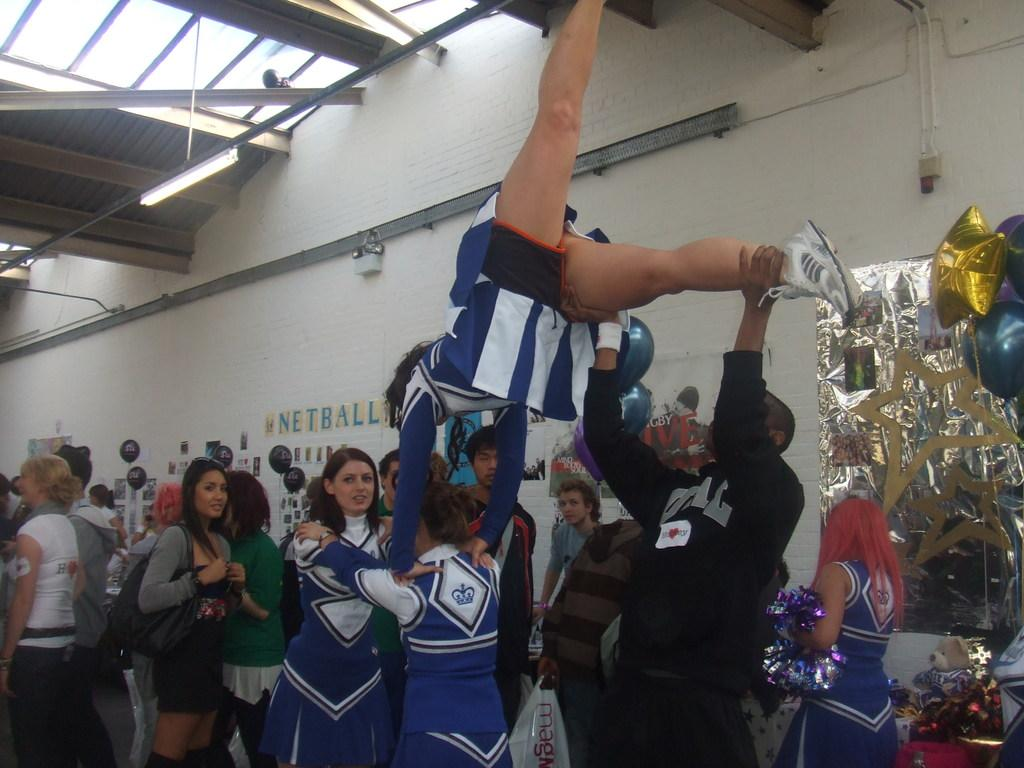<image>
Give a short and clear explanation of the subsequent image. A cheerleading squad stand in a stadium with the word netball stuck on the wall. 